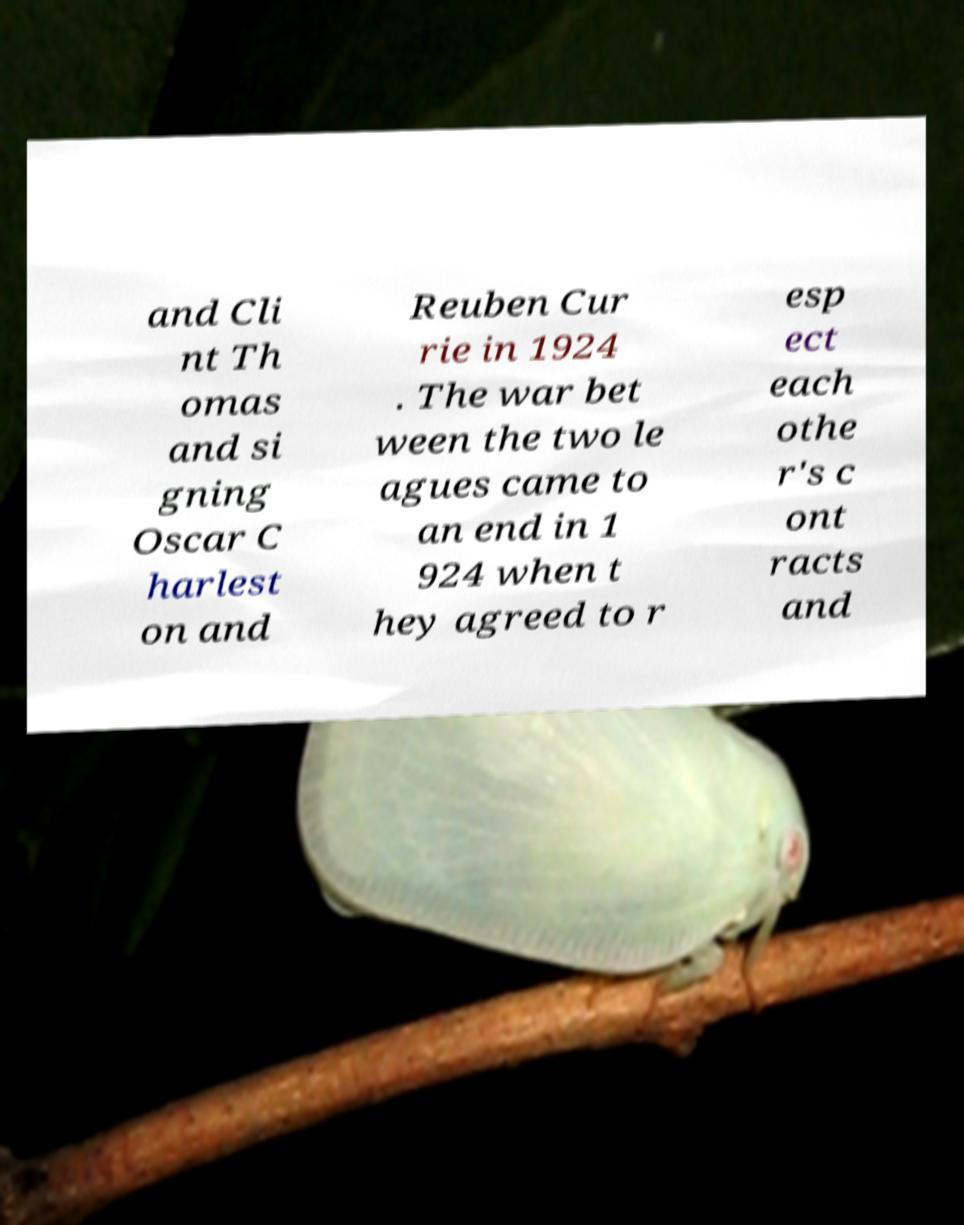Could you assist in decoding the text presented in this image and type it out clearly? and Cli nt Th omas and si gning Oscar C harlest on and Reuben Cur rie in 1924 . The war bet ween the two le agues came to an end in 1 924 when t hey agreed to r esp ect each othe r's c ont racts and 